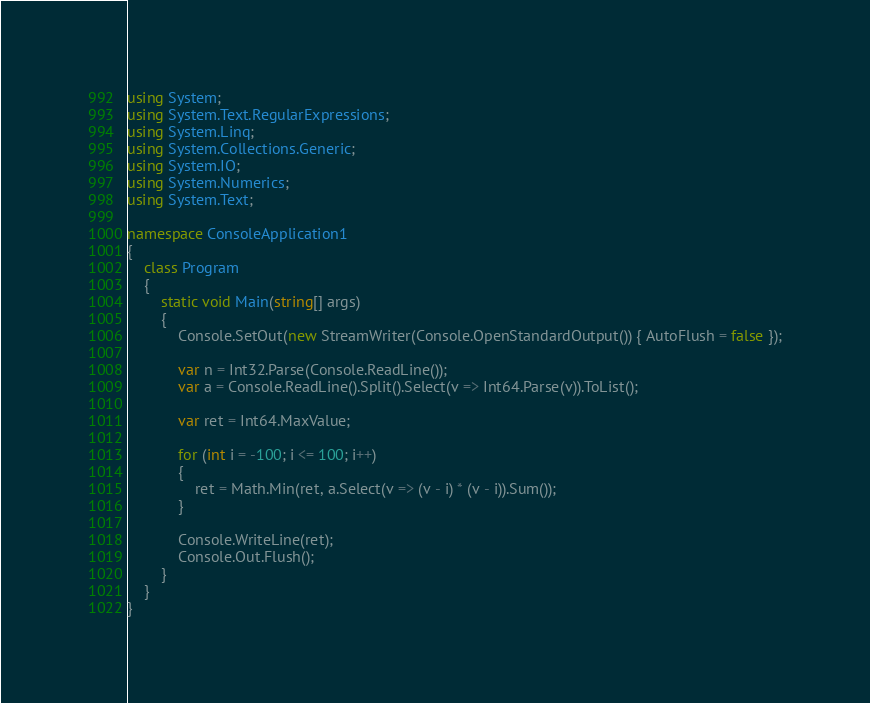<code> <loc_0><loc_0><loc_500><loc_500><_C#_>using System;
using System.Text.RegularExpressions;
using System.Linq;
using System.Collections.Generic;
using System.IO;
using System.Numerics;
using System.Text;

namespace ConsoleApplication1
{
    class Program
    {
        static void Main(string[] args)
        {
            Console.SetOut(new StreamWriter(Console.OpenStandardOutput()) { AutoFlush = false });

            var n = Int32.Parse(Console.ReadLine());
            var a = Console.ReadLine().Split().Select(v => Int64.Parse(v)).ToList();

            var ret = Int64.MaxValue;

            for (int i = -100; i <= 100; i++)
            {
                ret = Math.Min(ret, a.Select(v => (v - i) * (v - i)).Sum());
            }

            Console.WriteLine(ret);
            Console.Out.Flush();
        }
    }
}</code> 